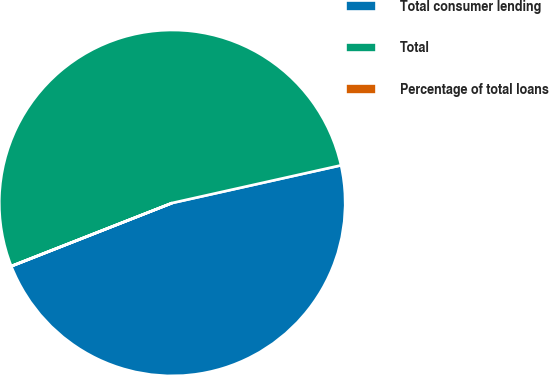Convert chart to OTSL. <chart><loc_0><loc_0><loc_500><loc_500><pie_chart><fcel>Total consumer lending<fcel>Total<fcel>Percentage of total loans<nl><fcel>47.52%<fcel>52.45%<fcel>0.02%<nl></chart> 